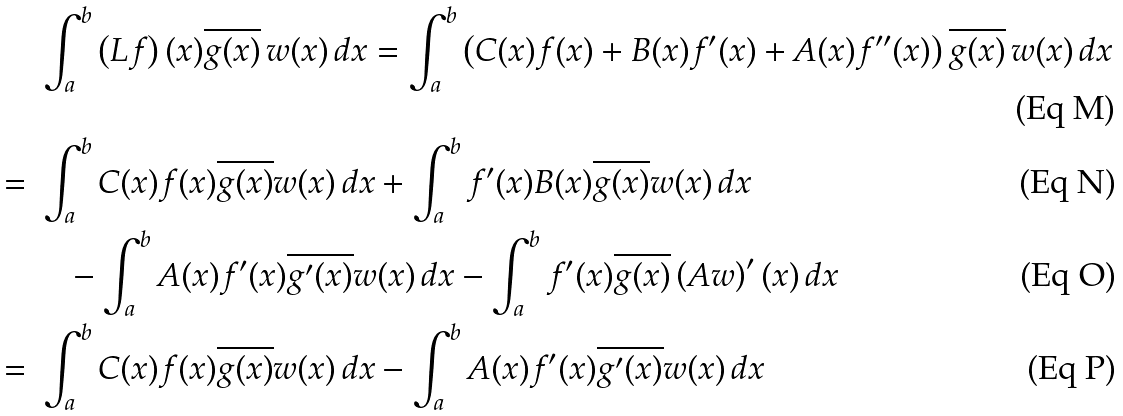<formula> <loc_0><loc_0><loc_500><loc_500>& \, \int _ { a } ^ { b } \left ( L f \right ) ( x ) \overline { g ( x ) } \, w ( x ) \, d x = \int _ { a } ^ { b } \left ( C ( x ) f ( x ) + B ( x ) f ^ { \prime } ( x ) + A ( x ) f ^ { \prime \prime } ( x ) \right ) \overline { g ( x ) } \, w ( x ) \, d x \\ = \, & \, \int _ { a } ^ { b } C ( x ) f ( x ) \overline { g ( x ) } w ( x ) \, d x + \int _ { a } ^ { b } f ^ { \prime } ( x ) B ( x ) \overline { g ( x ) } w ( x ) \, d x \\ & \quad - \int _ { a } ^ { b } A ( x ) f ^ { \prime } ( x ) \overline { g ^ { \prime } ( x ) } w ( x ) \, d x - \int _ { a } ^ { b } f ^ { \prime } ( x ) \overline { g ( x ) } \left ( A w \right ) ^ { \prime } ( x ) \, d x \\ = \, & \, \int _ { a } ^ { b } C ( x ) f ( x ) \overline { g ( x ) } w ( x ) \, d x - \int _ { a } ^ { b } A ( x ) f ^ { \prime } ( x ) \overline { g ^ { \prime } ( x ) } w ( x ) \, d x</formula> 